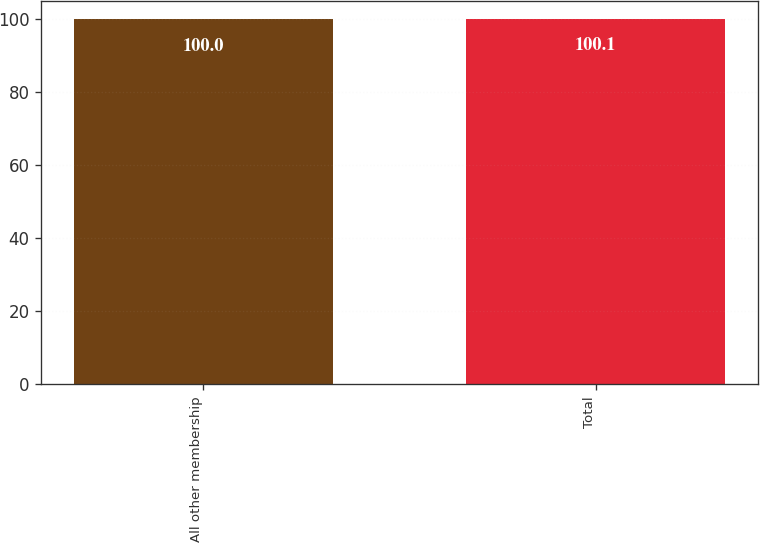<chart> <loc_0><loc_0><loc_500><loc_500><bar_chart><fcel>All other membership<fcel>Total<nl><fcel>100<fcel>100.1<nl></chart> 